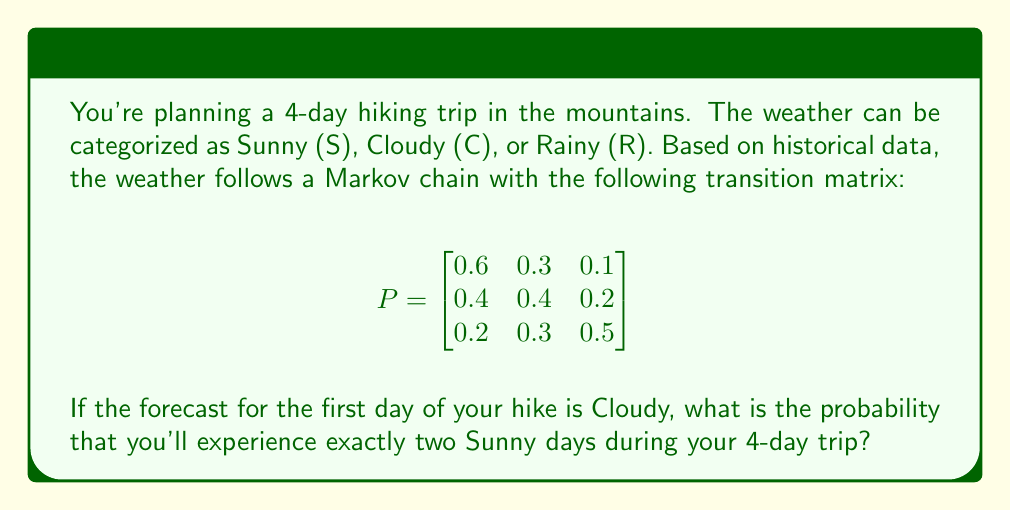Teach me how to tackle this problem. Let's approach this step-by-step:

1) First, we need to calculate the probabilities for each possible weather sequence that includes exactly two Sunny days over the 4-day period.

2) The possible sequences are:
   CSSS, CSSC, CSSR, CCSS, CSCS, CSRC, CRSS, CSRS

3) For each sequence, we'll calculate its probability using the Markov chain:

   P(CSSS) = 0.4 * 0.6 * 0.6 = 0.144
   P(CSSC) = 0.4 * 0.6 * 0.3 = 0.072
   P(CSSR) = 0.4 * 0.6 * 0.1 = 0.024
   P(CCSS) = 0.4 * 0.4 * 0.6 = 0.096
   P(CSCS) = 0.4 * 0.6 * 0.4 = 0.096
   P(CSRC) = 0.4 * 0.6 * 0.3 = 0.072
   P(CRSS) = 0.2 * 0.2 * 0.6 = 0.024
   P(CSRS) = 0.4 * 0.6 * 0.2 = 0.048

4) The total probability is the sum of all these individual probabilities:

   P(exactly two Sunny days) = 0.144 + 0.072 + 0.024 + 0.096 + 0.096 + 0.072 + 0.024 + 0.048 = 0.576

5) Therefore, the probability of experiencing exactly two Sunny days during the 4-day trip, given that the first day is Cloudy, is 0.576 or 57.6%.
Answer: 0.576 